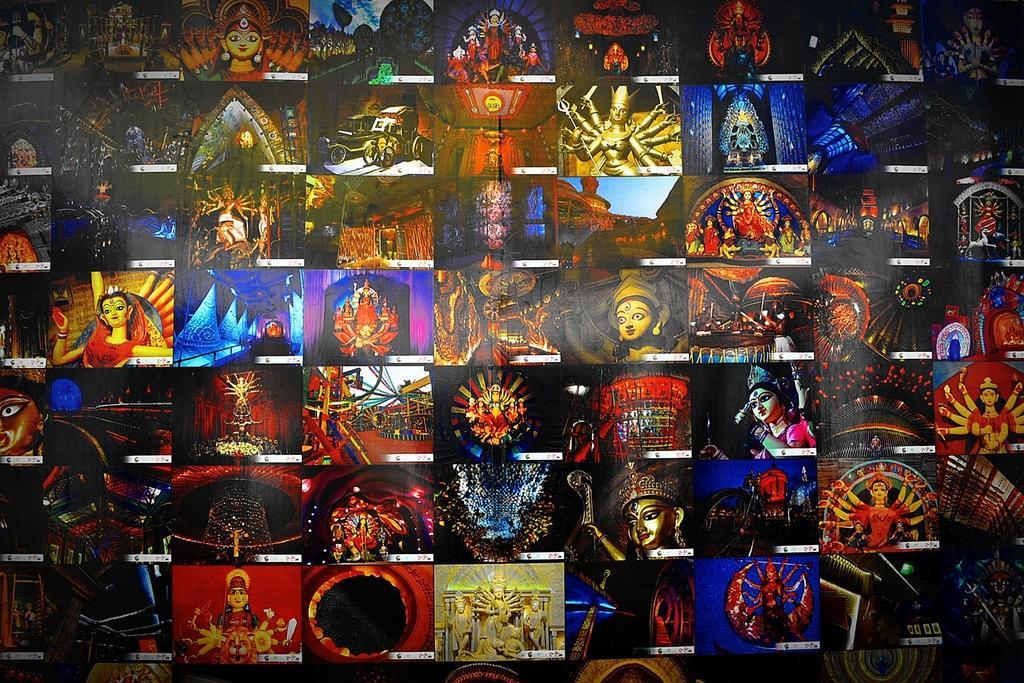Could you give a brief overview of what you see in this image? This is an edited image and made as college image. In all the pictures, I can see few idols and statues. 